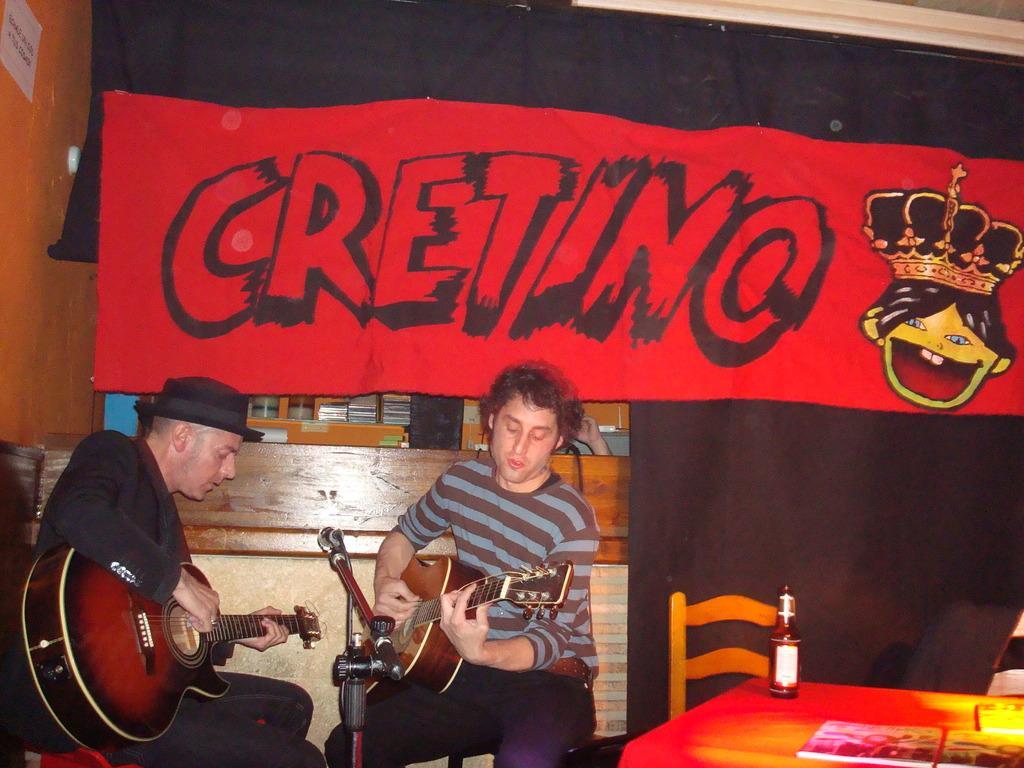Could you give a brief overview of what you see in this image? These two persons are sitting and playing guitar. We can see microphone with stand,chair,table on the table there are bottle,books. On the background we can see banner,wall. 